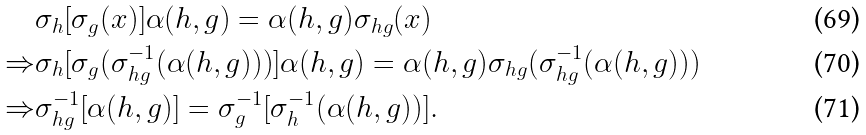Convert formula to latex. <formula><loc_0><loc_0><loc_500><loc_500>& \sigma _ { h } [ \sigma _ { g } ( x ) ] \alpha ( h , g ) = \alpha ( h , g ) \sigma _ { h g } ( x ) \\ \Rightarrow & \sigma _ { h } [ \sigma _ { g } ( \sigma _ { h g } ^ { - 1 } ( \alpha ( h , g ) ) ) ] \alpha ( h , g ) = \alpha ( h , g ) \sigma _ { h g } ( \sigma _ { h g } ^ { - 1 } ( \alpha ( h , g ) ) ) \\ \Rightarrow & \sigma _ { h g } ^ { - 1 } [ \alpha ( h , g ) ] = \sigma _ { g } ^ { - 1 } [ \sigma _ { h } ^ { - 1 } ( \alpha ( h , g ) ) ] .</formula> 